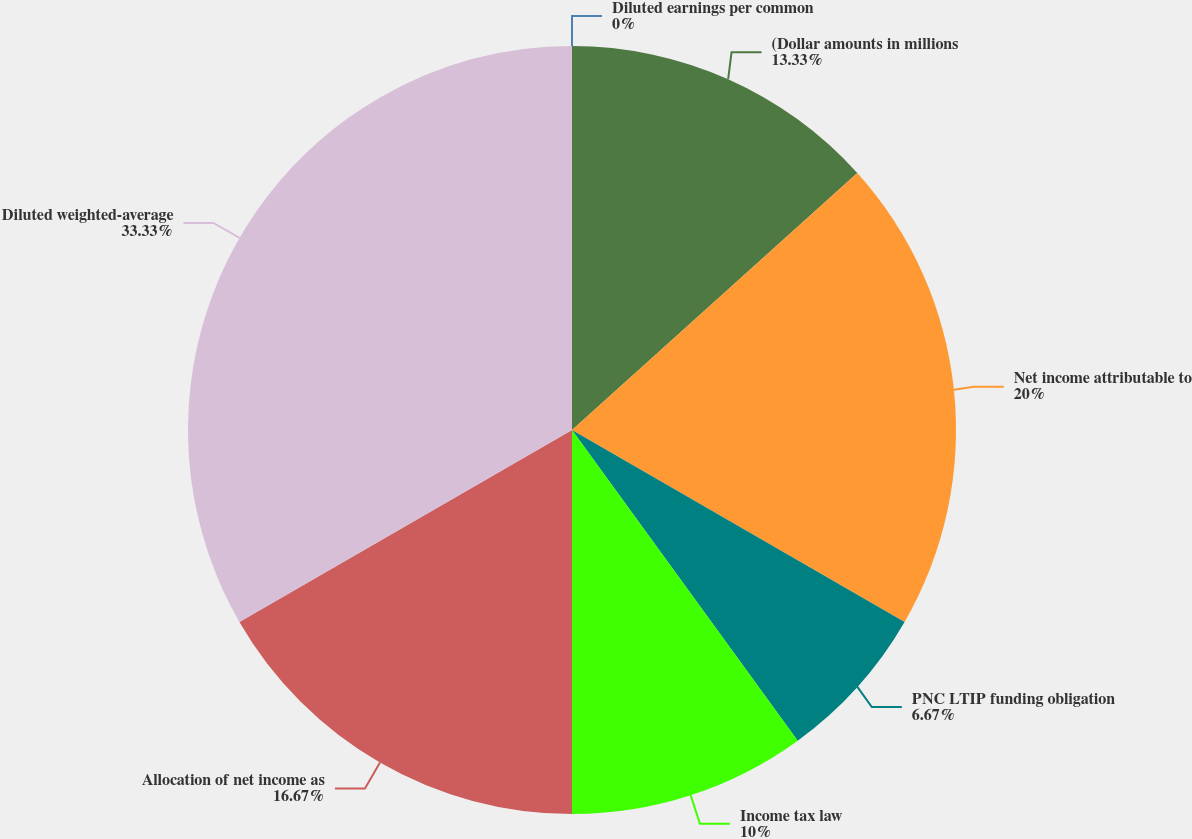Convert chart to OTSL. <chart><loc_0><loc_0><loc_500><loc_500><pie_chart><fcel>(Dollar amounts in millions<fcel>Net income attributable to<fcel>PNC LTIP funding obligation<fcel>Income tax law<fcel>Allocation of net income as<fcel>Diluted weighted-average<fcel>Diluted earnings per common<nl><fcel>13.33%<fcel>20.0%<fcel>6.67%<fcel>10.0%<fcel>16.67%<fcel>33.33%<fcel>0.0%<nl></chart> 